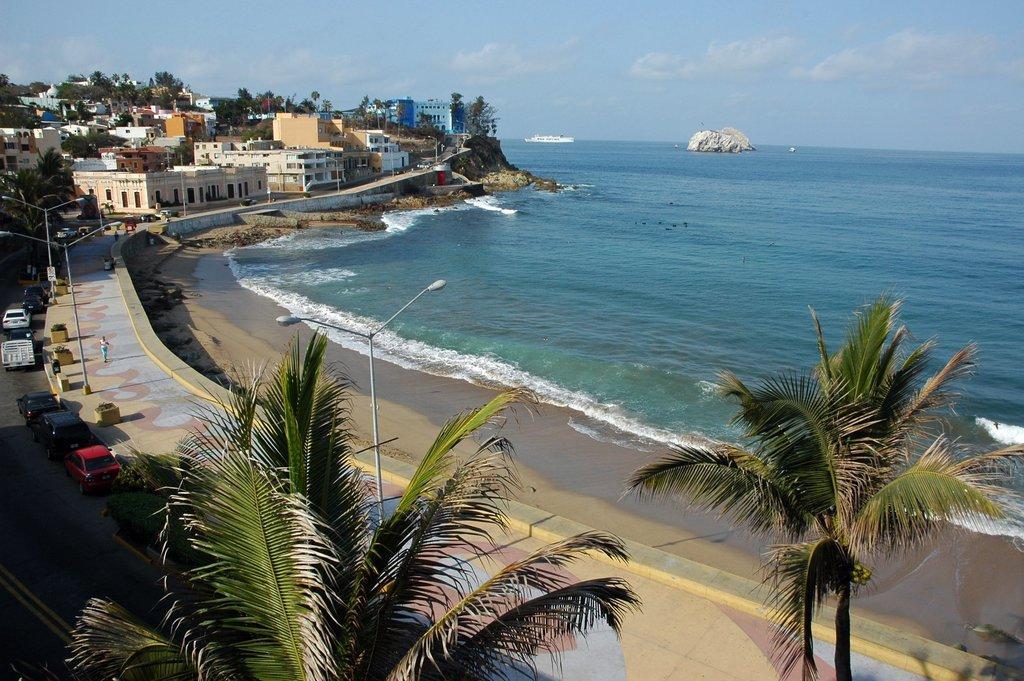Could you give a brief overview of what you see in this image? In this image there is a person walking on the pavement having street lights. Bottom of the image there are trees. Left side there are vehicles on the road. There are buildings and trees on the land. There is a ship sailing on the water having tides. There is a rock on the water. Top of the image there is sky with some clouds. 